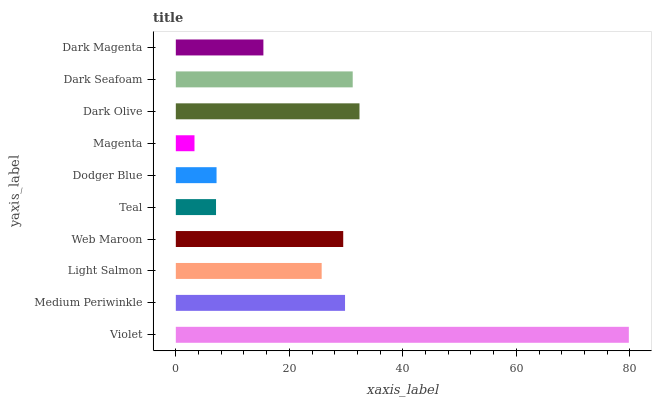Is Magenta the minimum?
Answer yes or no. Yes. Is Violet the maximum?
Answer yes or no. Yes. Is Medium Periwinkle the minimum?
Answer yes or no. No. Is Medium Periwinkle the maximum?
Answer yes or no. No. Is Violet greater than Medium Periwinkle?
Answer yes or no. Yes. Is Medium Periwinkle less than Violet?
Answer yes or no. Yes. Is Medium Periwinkle greater than Violet?
Answer yes or no. No. Is Violet less than Medium Periwinkle?
Answer yes or no. No. Is Web Maroon the high median?
Answer yes or no. Yes. Is Light Salmon the low median?
Answer yes or no. Yes. Is Teal the high median?
Answer yes or no. No. Is Web Maroon the low median?
Answer yes or no. No. 